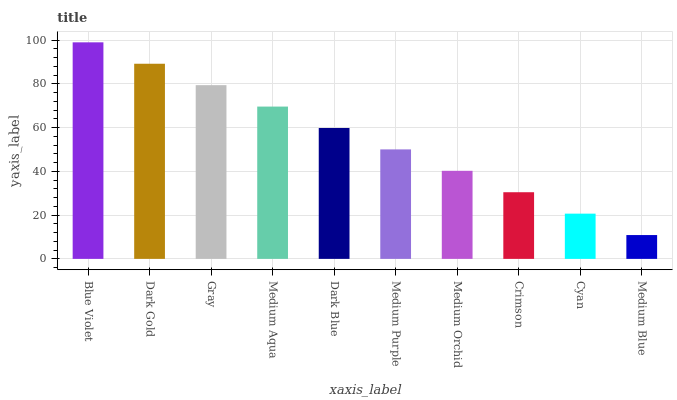Is Medium Blue the minimum?
Answer yes or no. Yes. Is Blue Violet the maximum?
Answer yes or no. Yes. Is Dark Gold the minimum?
Answer yes or no. No. Is Dark Gold the maximum?
Answer yes or no. No. Is Blue Violet greater than Dark Gold?
Answer yes or no. Yes. Is Dark Gold less than Blue Violet?
Answer yes or no. Yes. Is Dark Gold greater than Blue Violet?
Answer yes or no. No. Is Blue Violet less than Dark Gold?
Answer yes or no. No. Is Dark Blue the high median?
Answer yes or no. Yes. Is Medium Purple the low median?
Answer yes or no. Yes. Is Blue Violet the high median?
Answer yes or no. No. Is Cyan the low median?
Answer yes or no. No. 